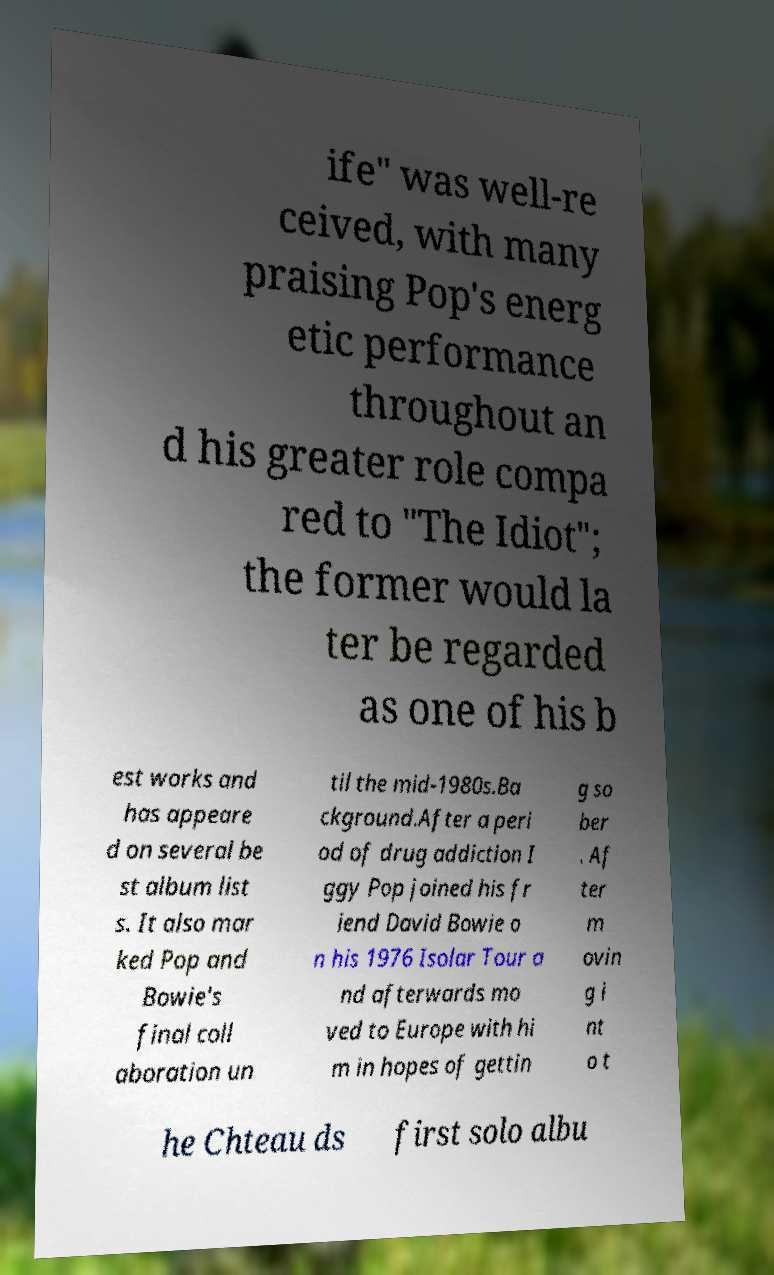What messages or text are displayed in this image? I need them in a readable, typed format. ife" was well-re ceived, with many praising Pop's energ etic performance throughout an d his greater role compa red to "The Idiot"; the former would la ter be regarded as one of his b est works and has appeare d on several be st album list s. It also mar ked Pop and Bowie's final coll aboration un til the mid-1980s.Ba ckground.After a peri od of drug addiction I ggy Pop joined his fr iend David Bowie o n his 1976 Isolar Tour a nd afterwards mo ved to Europe with hi m in hopes of gettin g so ber . Af ter m ovin g i nt o t he Chteau ds first solo albu 